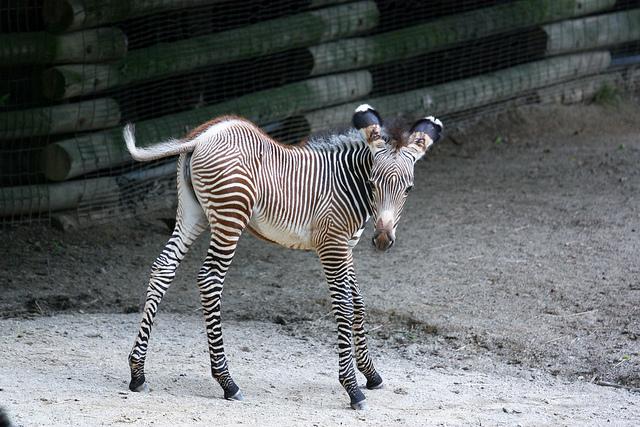Is this animal black and white?
Write a very short answer. Yes. Is this a baby?
Be succinct. Yes. Is this a cow?
Answer briefly. No. 